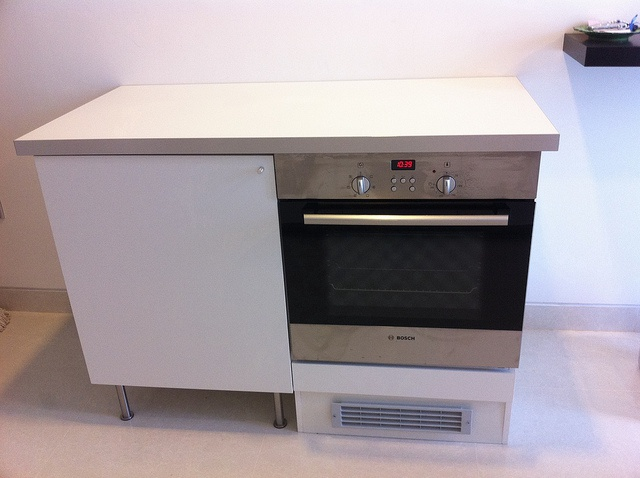Describe the objects in this image and their specific colors. I can see oven in darkgray, black, and gray tones and microwave in darkgray, black, and gray tones in this image. 